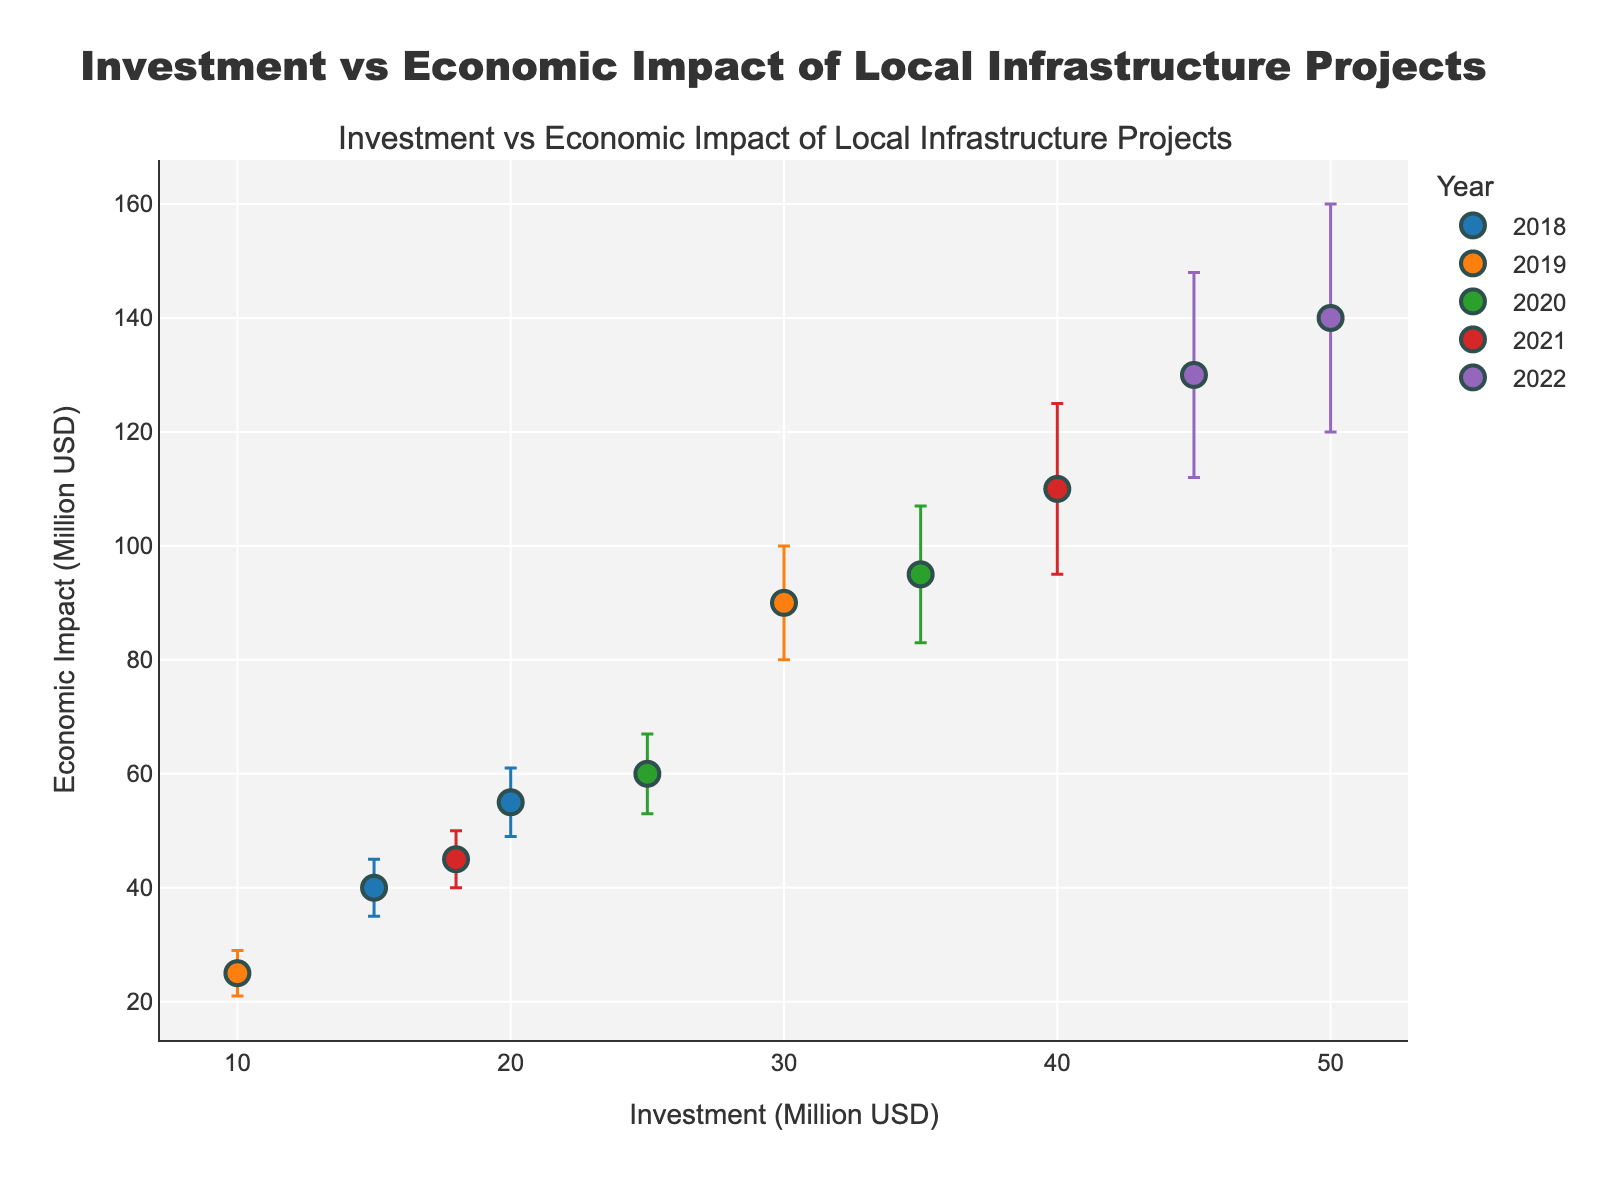What's the title of the plot? The title is usually displayed at the top center of the plot which summarizes the main point of the figure.
Answer: Investment vs Economic Impact of Local Infrastructure Projects What's the range of investment values on the x-axis? The x-axis typically displays the range of values from the minima to the maxima observed in the data. Here, the minimum investment is 10 million USD and the maximum is 50 million USD.
Answer: 10 to 50 million USD What year's data has the highest economic impact? By observing the vertical position of the points, the highest economic impact reaches up to 140 million USD. This point corresponds to the investment in the year 2022.
Answer: 2022 Which project had the highest error margin in economic impact? Error margins can be identified by the size of the error bars. The project with the largest error is the one with the longest error bar, which is the Riverfront Shopping Complex project.
Answer: Riverfront Shopping Complex How does the economic impact of the Central Hospital Renovation compare to the Southtown Tech Hub Establishment? By comparing their positions on the y-axis, Central Hospital Renovation has an economic impact of 110 million USD, while Southtown Tech Hub Establishment has an impact of 130 million USD.
Answer: Southtown Tech Hub Establishment had a higher impact What's the average economic impact of projects in the year 2020? First, identify the projects in 2020. Add their economic impacts together and then divide by the number of projects: (60 + 95) / 2 = 77.5 million USD.
Answer: 77.5 million USD Which project, between Smithville Bridge Construction and Eastwood Community Center Upgrade, had a higher economic impact and by how much? Check the y-axis values of the points corresponding to the projects in 2018 and 2019 respectively. Smithville Bridge Construction had an economic impact of 55 million USD, whereas Eastwood Community Center Upgrade had an impact of 25 million USD. The difference is 55 - 25 = 30 million USD.
Answer: Smithville Bridge Construction by 30 million USD How many data points for the year 2021 are present in the plot? Each marker represents a project for a specific year. Count the markers with the same color that corresponds to 2021. There are 2 data points for the year 2021.
Answer: 2 What is the error margin for the Northside Highway Expansion project? Identify the Northside Highway Expansion project in the year 2019 and read its error margin from the error bars, which is given in the dataset as 10 million USD.
Answer: 10 million USD 